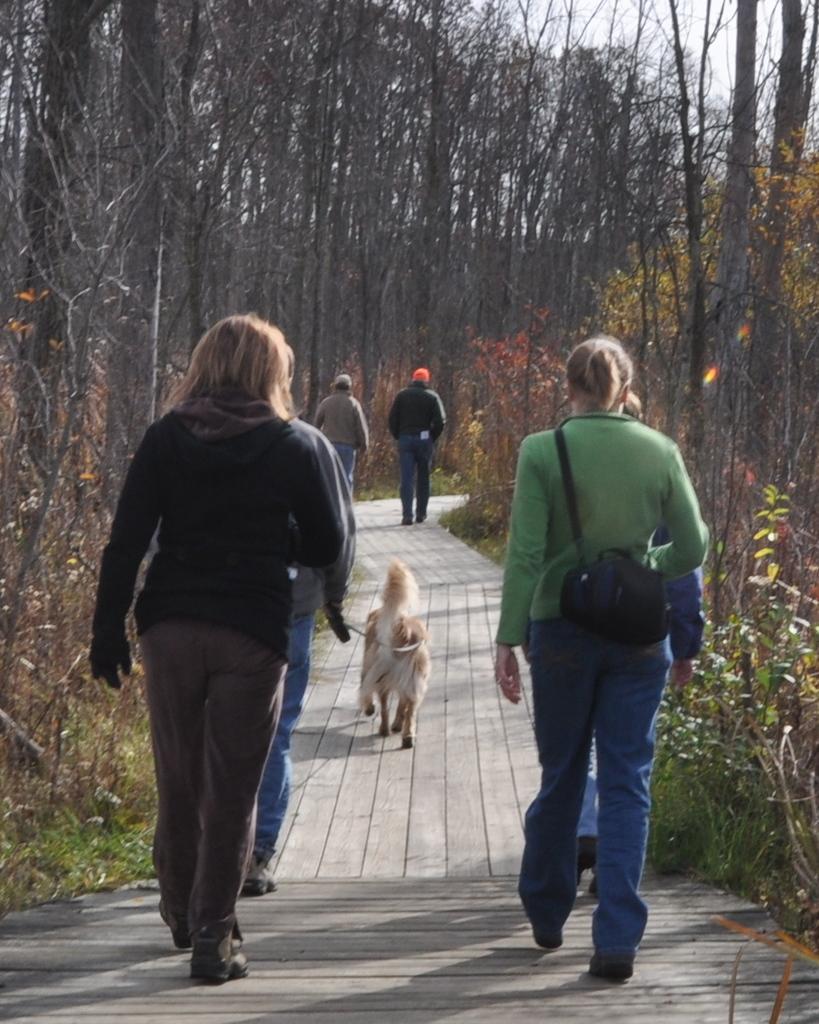Can you describe this image briefly? In this image I see the path on which there are few people and I see a dog over here which is of white and cream in color and I see the plants and trees and I see the sky. 